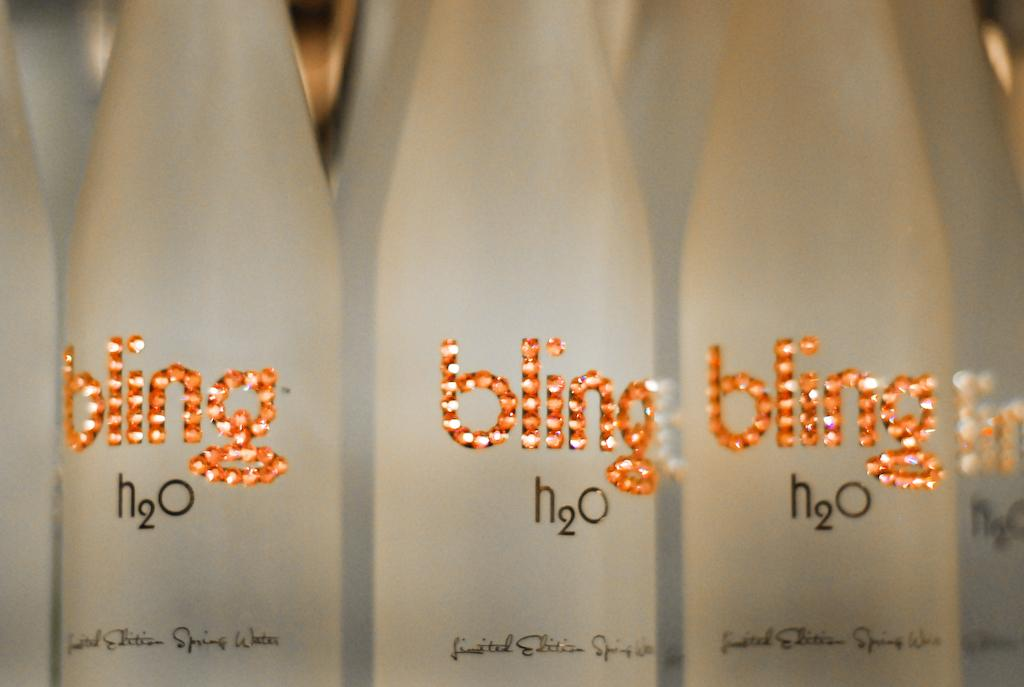<image>
Present a compact description of the photo's key features. An orange and white lighted bling logo on a cloudy glass water bottle. 